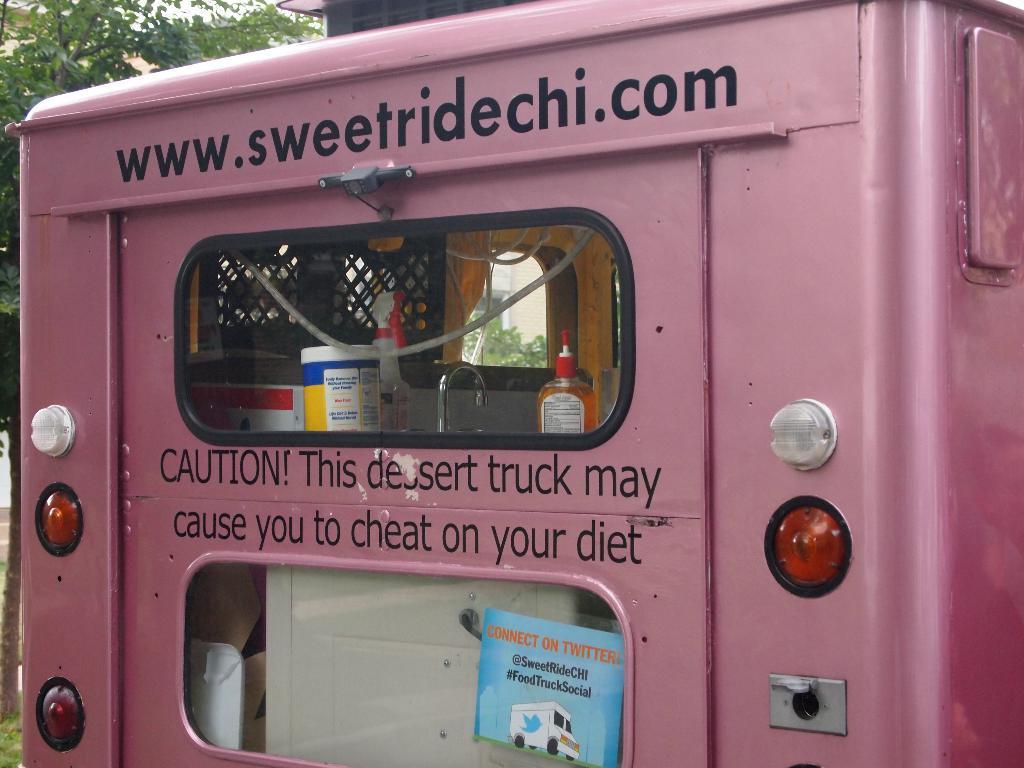Could you give a brief overview of what you see in this image? This picture is clicked outside. In the center there is a pink color metal object seems to be the vehicle and we can see the windows of the vehicle and through the windows we can see the bottles and some other objects and we can see the text on the object. In the background there is a sky and we can see the trees. 